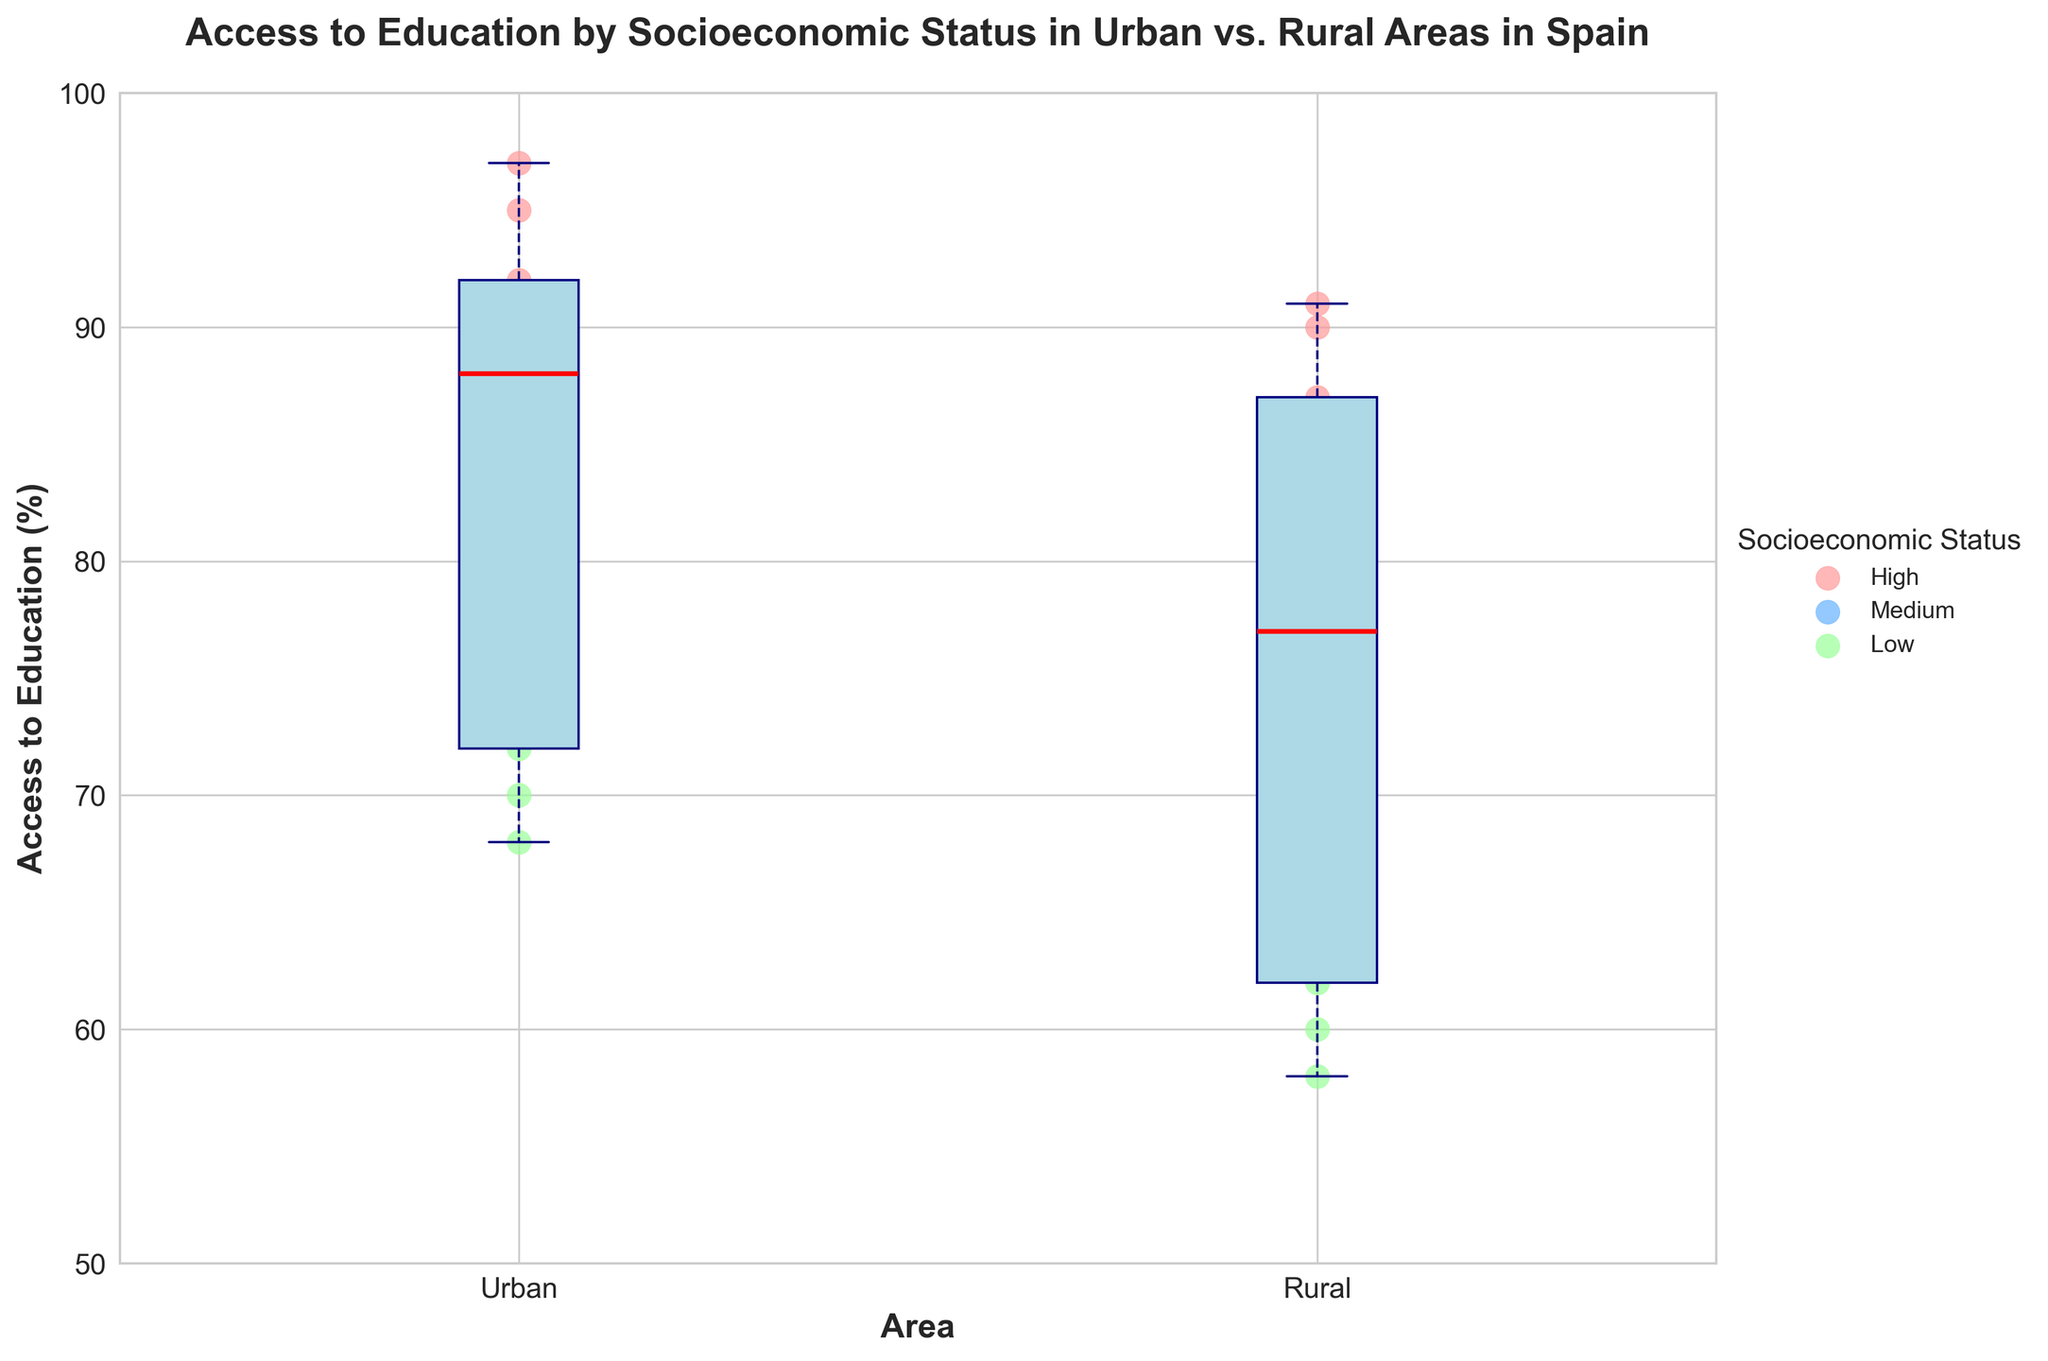What's the title of the figure? The title of the figure is clearly stated at the top.
Answer: Access to Education by Socioeconomic Status in Urban vs. Rural Areas in Spain What is the range of access to education for urban areas? The range of access to education in urban areas is determined by looking at the minimum and maximum points within the urban box plot.
Answer: 68-97% Which area has the higher median access to education? The median access to education is the line inside the box plot. We compare the median lines of the urban and rural box plots.
Answer: Urban What socioeconomic status has the highest scatter point in rural areas? By observing the scatter points in the second box plot (Rural), the highest scatter point is from 'High' socioeconomic status.
Answer: High How does access to education for medium socioeconomic status compare between urban and rural areas? We compare the scatter points labeled 'Medium' in both box plots.
Answer: Higher in urban areas What is the median access to education for rural areas? The median is the horizontal red line within the box. In rural areas, it falls at a certain point value.
Answer: 77 What is the interquartile range (IQR) for rural access to education? The IQR is the range between the 1st quartile (bottom of the box) and the 3rd quartile (top of the box) for the rural box plot.
Answer: 75-90 Which area has more variability in access to education? Variability can be assessed by the length of the box plots and the spread of the scatter points.
Answer: Urban Which socioeconomic status shows the biggest difference in access to education between urban and rural areas? By comparing the scatter points grouped by status, we notice which group has the largest gap between urban and rural.
Answer: Low What's the minimum access to education value for rural areas? The minimum value is the lowest data point on the rural box plot.
Answer: 58% 